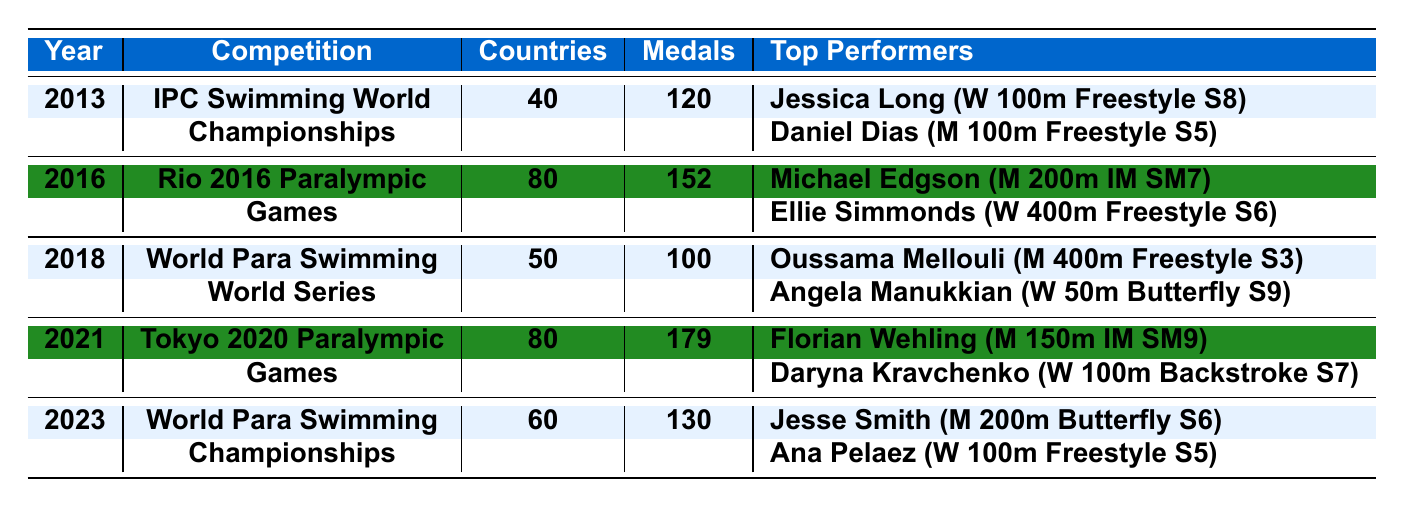What was the total medal count in the 2016 Rio Paralympic Games? The table states that the total medal count for the 2016 Rio Paralympic Games is 152, as indicated in the respective row.
Answer: 152 How many countries were represented at the IPC Swimming World Championships in 2013? According to the table, the number of countries represented at the IPC Swimming World Championships in 2013 is 40, as shown in the relevant row.
Answer: 40 Which athlete won the gold medal in the Women's 100m Freestyle at the 2023 World Para Swimming Championships? The table lists Ana Pelaez as the gold medalist in the Women's 100m Freestyle S5 at the 2023 World Para Swimming Championships in the corresponding row.
Answer: Ana Pelaez What was the average total medal count from 2013 to 2023? The total medal counts are 120, 152, 100, 179, and 130. Summing them up gives 120 + 152 + 100 + 179 + 130 = 681, and dividing by 5 (the number of competitions) results in an average of 681/5 = 136.2.
Answer: 136.2 Which event had the least number of countries represented from 2013 to 2023? By examining the table, the IPC Swimming World Championships in 2013 had the least number of countries represented with 40, compared to 80 in 2016, 50 in 2018, 80 in 2021, and 60 in 2023.
Answer: IPC Swimming World Championships (2013) Did the total medal count in the 2021 Tokyo Paralympic Games exceed that of the 2018 World Para Swimming World Series? The total medal count for the 2021 Tokyo Paralympic Games is 179, while for the 2018 World Para Swimming World Series it is 100. Since 179 > 100, the statement is true.
Answer: Yes What events featured gold medalists from both men's and women's categories in the same competition? By reviewing the table, the 2016 Rio Paralympic Games and 2021 Tokyo Paralympic Games both featured gold medalists in both men's and women's categories.
Answer: 2016 Rio and 2021 Tokyo What is the difference in the total medal counts between 2013 and 2023? The total medal count for 2013 is 120 and for 2023 it is 130. The difference is calculated as 130 - 120 = 10.
Answer: 10 Which competition had the highest number of represented countries? The 2016 Rio Paralympic Games had the highest number of represented countries, which is 80, more than the other competitions listed in the table.
Answer: 2016 Rio Paralympic Games 